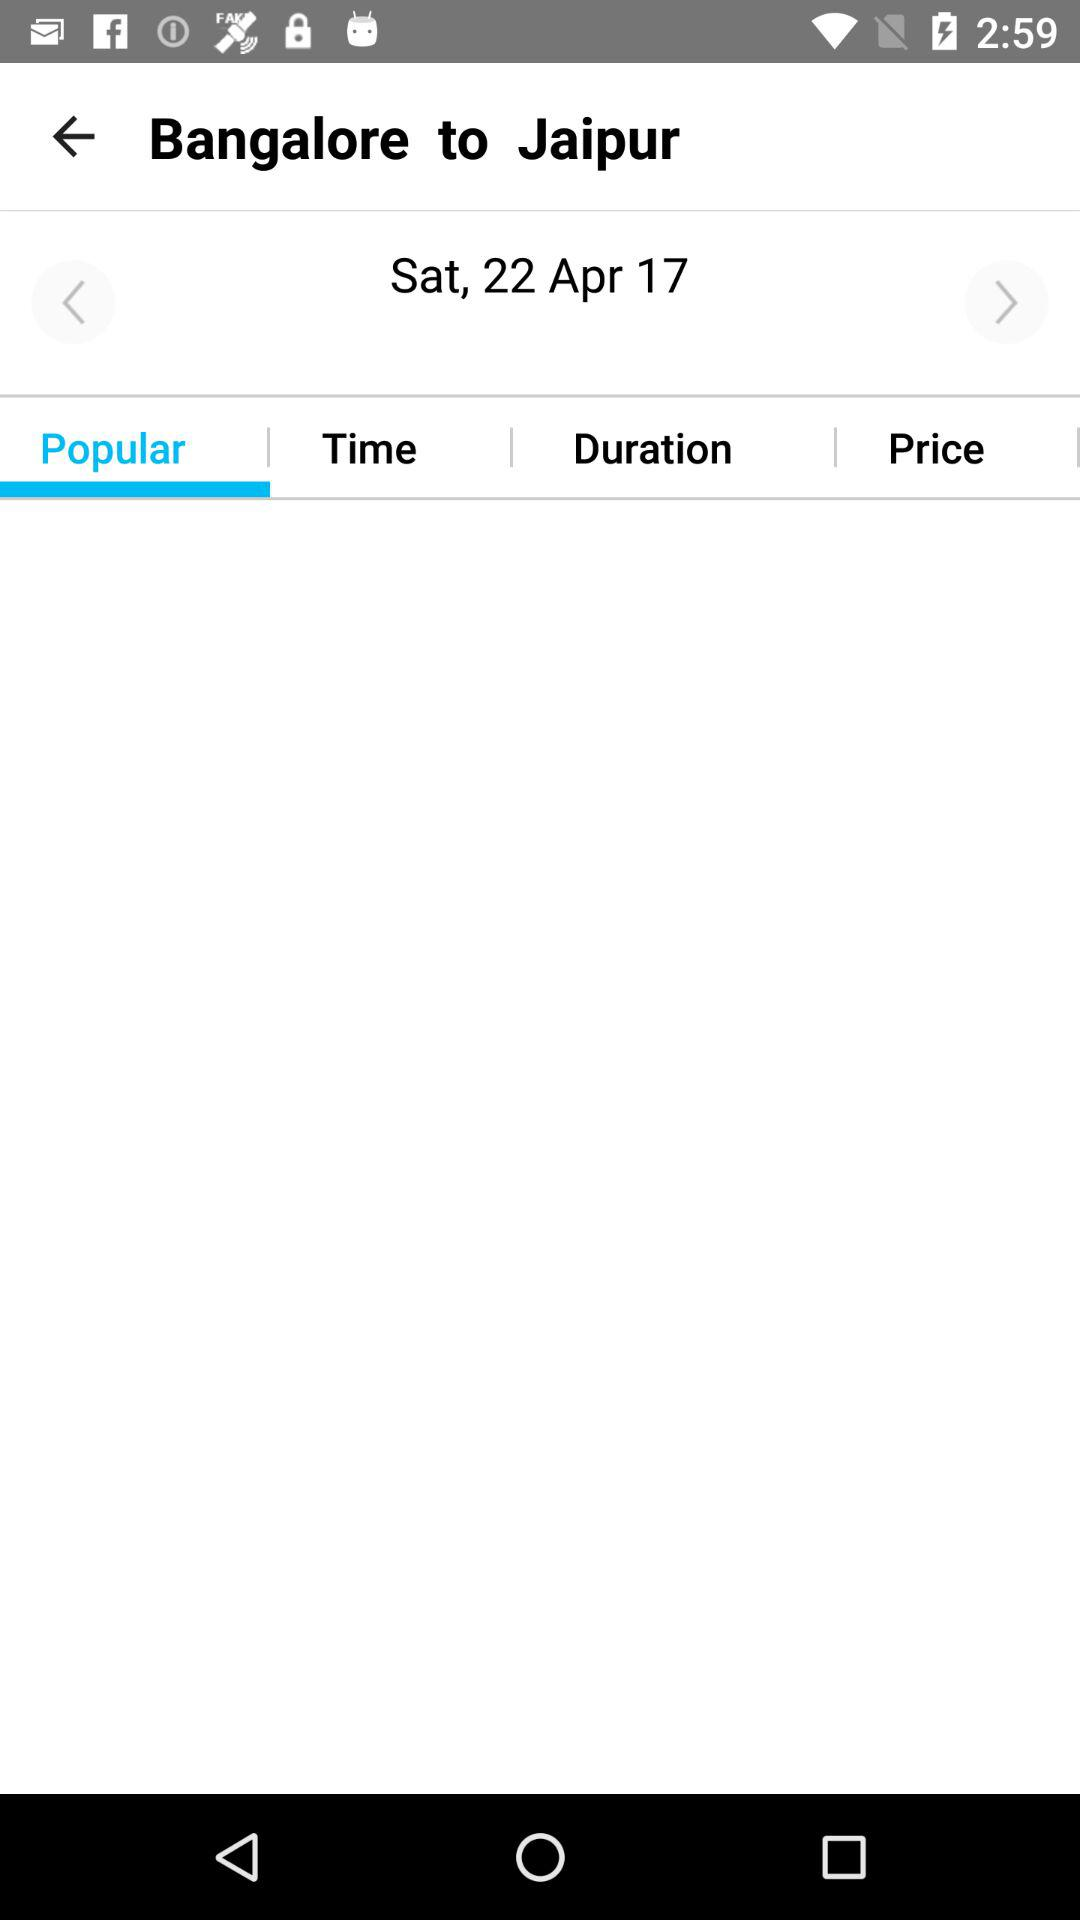Which tab is selected? The selected tab is "Popular". 